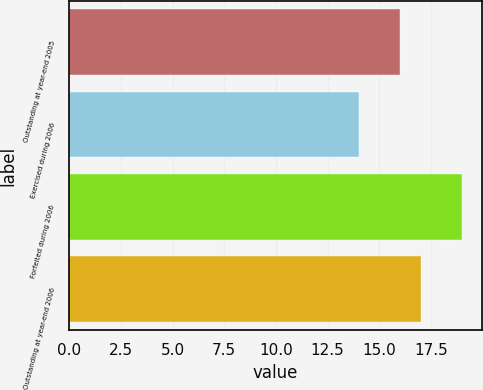Convert chart to OTSL. <chart><loc_0><loc_0><loc_500><loc_500><bar_chart><fcel>Outstanding at year-end 2005<fcel>Exercised during 2006<fcel>Forfeited during 2006<fcel>Outstanding at year-end 2006<nl><fcel>16<fcel>14<fcel>19<fcel>17<nl></chart> 